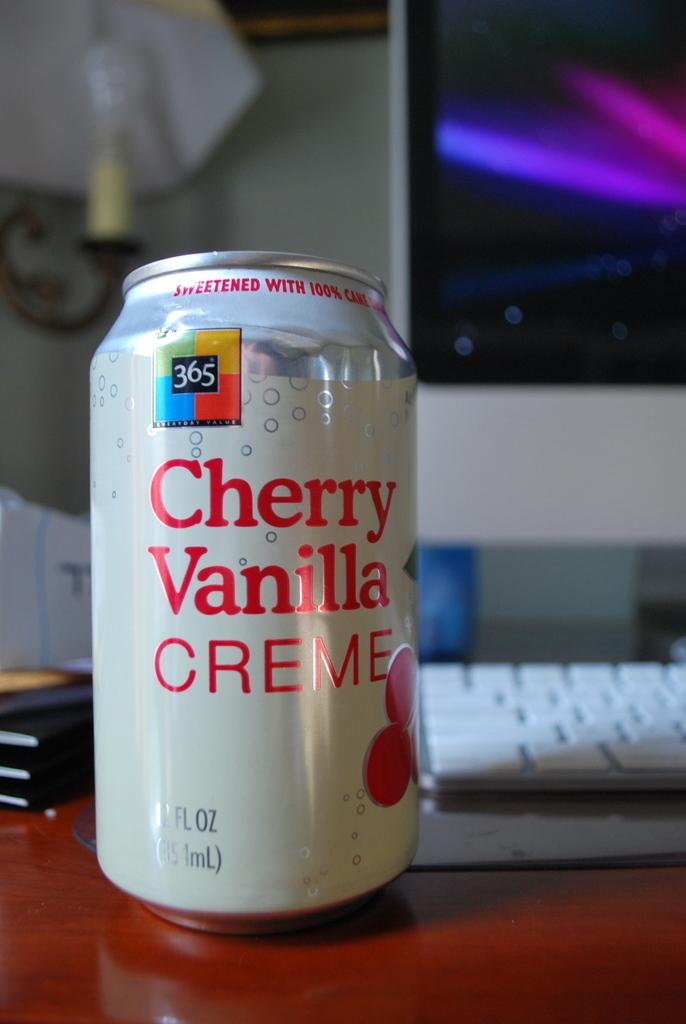<image>
Offer a succinct explanation of the picture presented. A white can of soda that says Cherry Vanilla Creme is on a computer desk. 